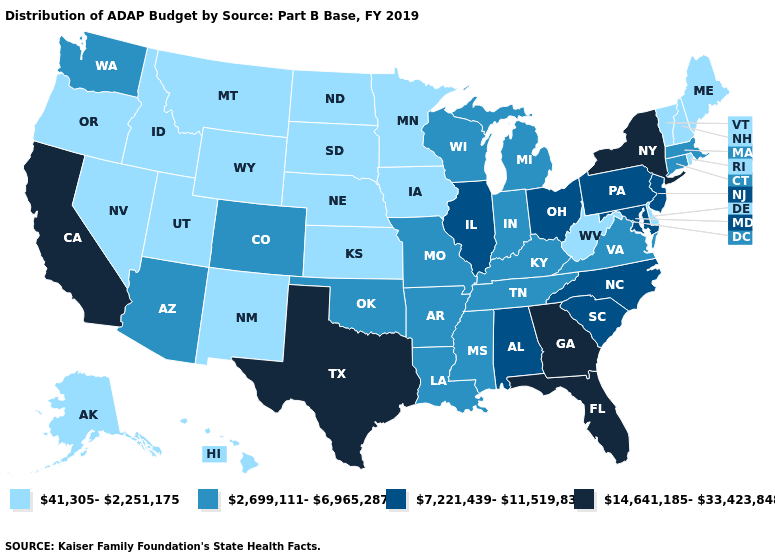Does Texas have the highest value in the USA?
Quick response, please. Yes. What is the lowest value in the Northeast?
Short answer required. 41,305-2,251,175. Among the states that border South Carolina , does Georgia have the highest value?
Give a very brief answer. Yes. What is the value of Oregon?
Answer briefly. 41,305-2,251,175. Does the map have missing data?
Write a very short answer. No. What is the highest value in states that border Michigan?
Quick response, please. 7,221,439-11,519,837. What is the value of Nevada?
Write a very short answer. 41,305-2,251,175. Does Michigan have the lowest value in the MidWest?
Quick response, please. No. Does Michigan have a lower value than Vermont?
Answer briefly. No. What is the lowest value in the MidWest?
Answer briefly. 41,305-2,251,175. What is the lowest value in the USA?
Quick response, please. 41,305-2,251,175. What is the value of Oregon?
Short answer required. 41,305-2,251,175. What is the lowest value in the USA?
Concise answer only. 41,305-2,251,175. What is the highest value in states that border Idaho?
Short answer required. 2,699,111-6,965,287. Among the states that border Georgia , which have the highest value?
Short answer required. Florida. 